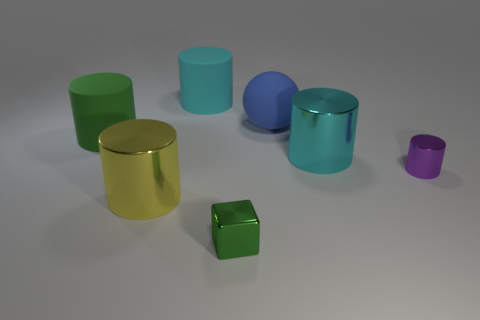There is a rubber ball; is its color the same as the big rubber cylinder that is to the left of the large yellow cylinder?
Your answer should be compact. No. What number of tiny purple cubes are there?
Make the answer very short. 0. How many things are small purple cylinders or big objects?
Offer a terse response. 6. There is a rubber thing that is the same color as the tiny cube; what is its size?
Give a very brief answer. Large. Are there any green rubber cylinders behind the large green object?
Your answer should be very brief. No. Are there more yellow cylinders in front of the small metal cube than green shiny objects behind the cyan rubber thing?
Offer a very short reply. No. What size is the cyan matte thing that is the same shape as the large cyan metallic object?
Keep it short and to the point. Large. How many cubes are either small gray shiny things or yellow shiny objects?
Ensure brevity in your answer.  0. There is a cylinder that is the same color as the block; what is its material?
Offer a terse response. Rubber. Is the number of large rubber things that are right of the tiny green metal object less than the number of large matte objects to the right of the small cylinder?
Ensure brevity in your answer.  No. 